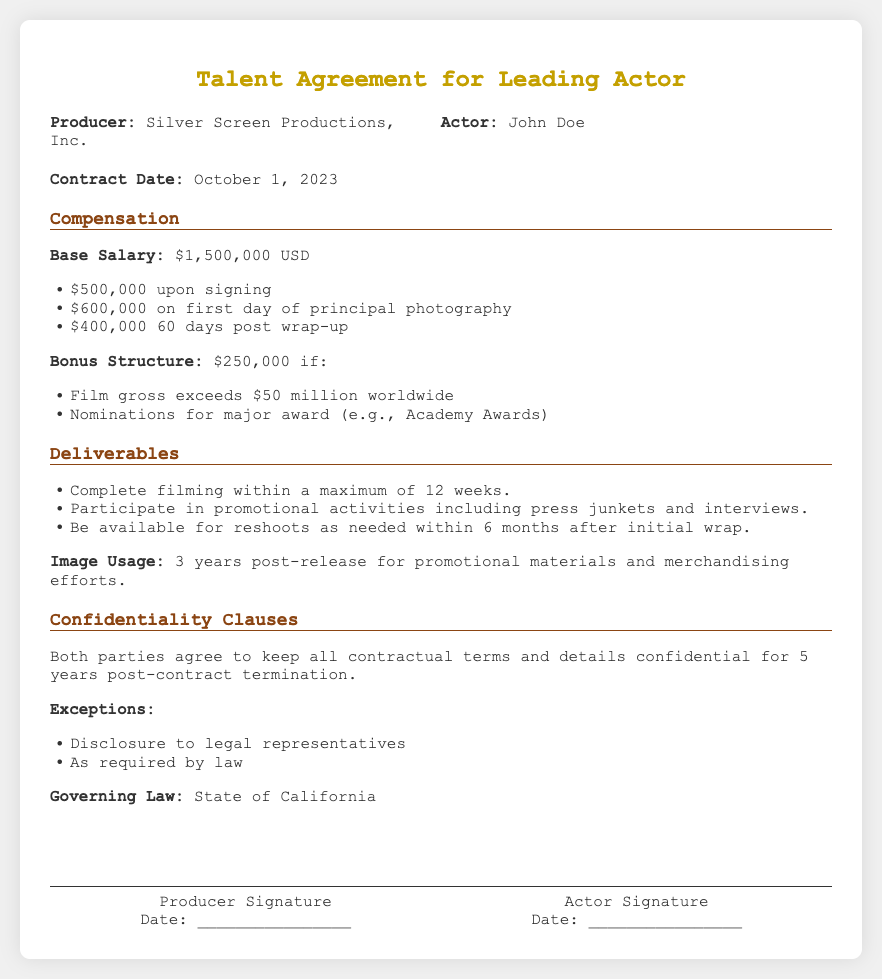What is the name of the producer? The producer named in the document is Silver Screen Productions, Inc.
Answer: Silver Screen Productions, Inc What is the base salary for the actor? The document states that the base salary is $1,500,000 USD.
Answer: $1,500,000 USD How much is the first payment upon signing? The first payment upon signing is specified as $500,000.
Answer: $500,000 What is the bonus if the film gross exceeds $50 million? The bonus if the film grosses exceeds $50 million is $250,000.
Answer: $250,000 How long does the actor have to complete filming? The actor must complete filming within a maximum of 12 weeks as stated in the document.
Answer: 12 weeks How long is the image usage period post-release? The image usage period post-release for promotional materials is 3 years.
Answer: 3 years What must the actor participate in for promotional activities? The actor must participate in press junkets and interviews as part of the promotional activities.
Answer: press junkets and interviews How many years does the confidentiality clause last? The confidentiality clause lasts for 5 years post-contract termination.
Answer: 5 years In which state is the governing law stipulated? The governing law stated in the document is the State of California.
Answer: State of California 